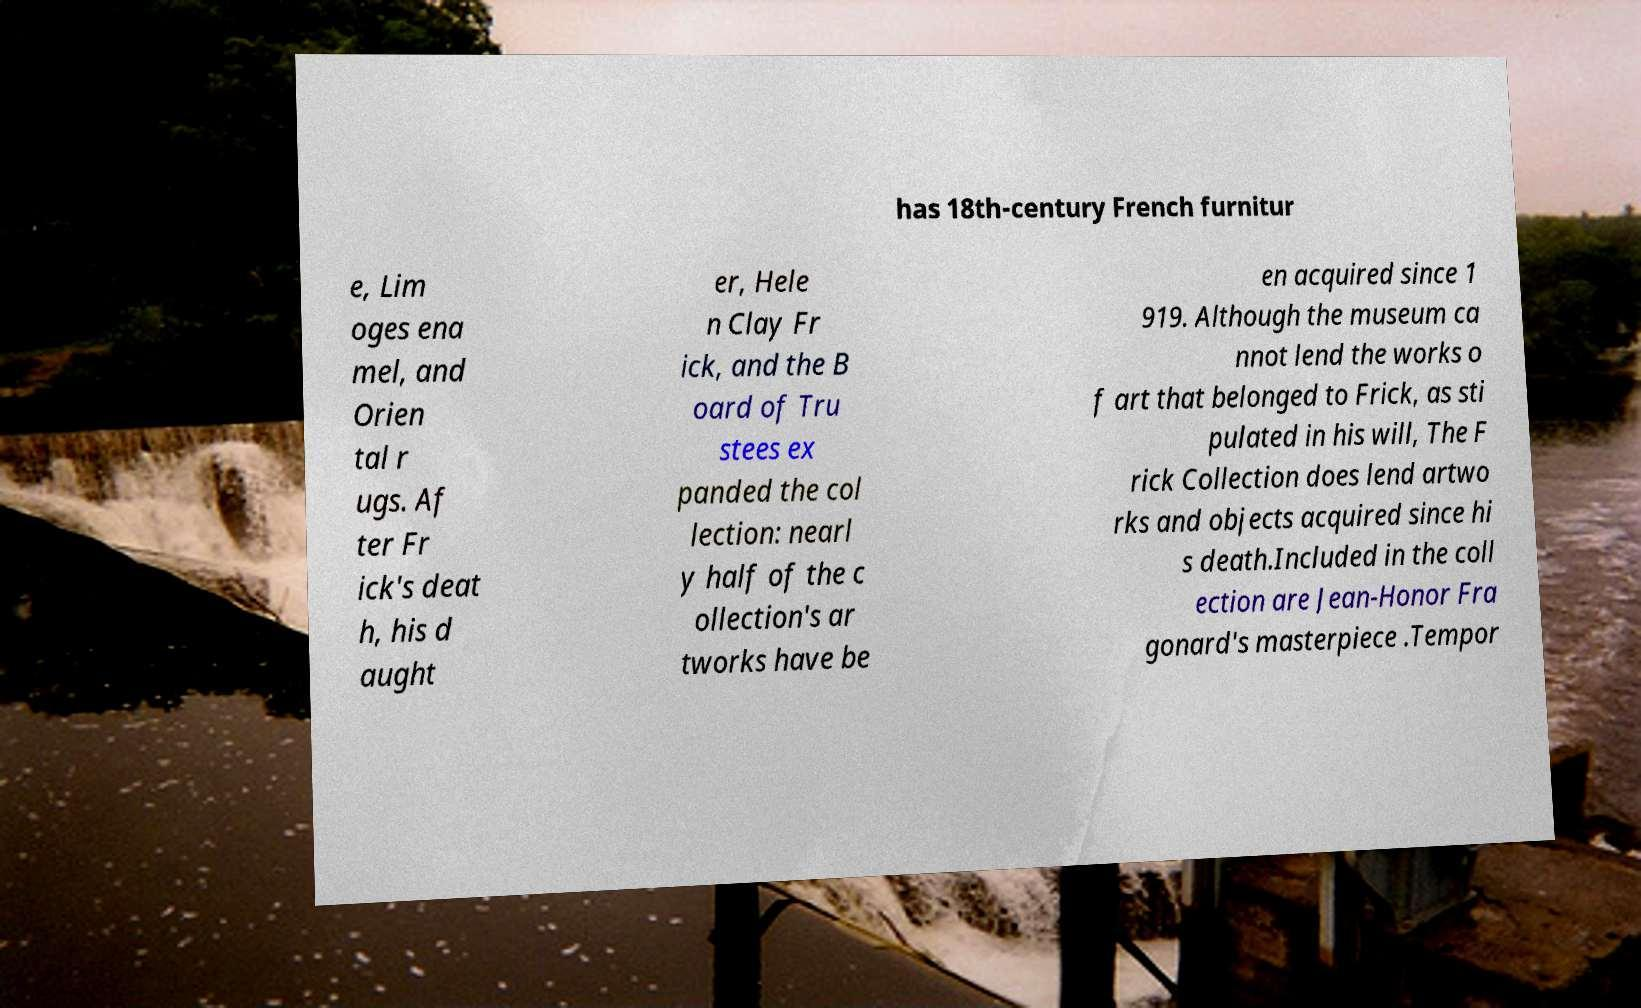Please identify and transcribe the text found in this image. has 18th-century French furnitur e, Lim oges ena mel, and Orien tal r ugs. Af ter Fr ick's deat h, his d aught er, Hele n Clay Fr ick, and the B oard of Tru stees ex panded the col lection: nearl y half of the c ollection's ar tworks have be en acquired since 1 919. Although the museum ca nnot lend the works o f art that belonged to Frick, as sti pulated in his will, The F rick Collection does lend artwo rks and objects acquired since hi s death.Included in the coll ection are Jean-Honor Fra gonard's masterpiece .Tempor 